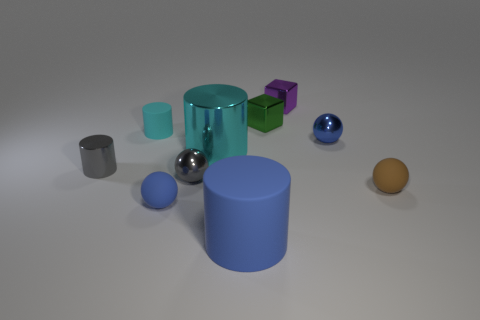Subtract all tiny gray balls. How many balls are left? 3 Subtract all gray balls. How many balls are left? 3 Subtract all blocks. How many objects are left? 8 Subtract 1 blocks. How many blocks are left? 1 Subtract all green cylinders. How many yellow spheres are left? 0 Subtract all small green metal spheres. Subtract all blue metal objects. How many objects are left? 9 Add 5 tiny purple shiny objects. How many tiny purple shiny objects are left? 6 Add 8 brown spheres. How many brown spheres exist? 9 Subtract 1 blue balls. How many objects are left? 9 Subtract all brown blocks. Subtract all gray cylinders. How many blocks are left? 2 